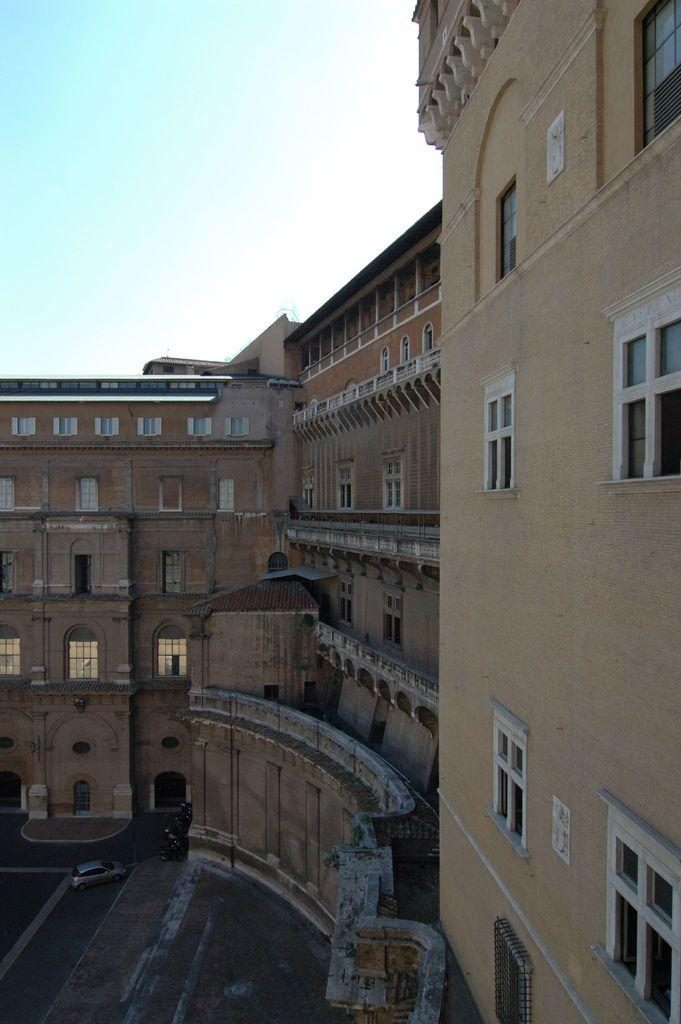What type of structure is present in the image? There is a building in the image. What feature can be seen on the building? The building has windows. What is located at the bottom of the image? There is a road at the bottom of the image. What can be seen on the road? There is a car on the road. What is visible at the top of the image? The sky is visible at the top of the image. How many children are sitting on the chairs in the image? There are no children or chairs present in the image. What type of kitty can be seen playing with the car in the image? There is no kitty present in the image, and the car is not shown to be playing with anything. 